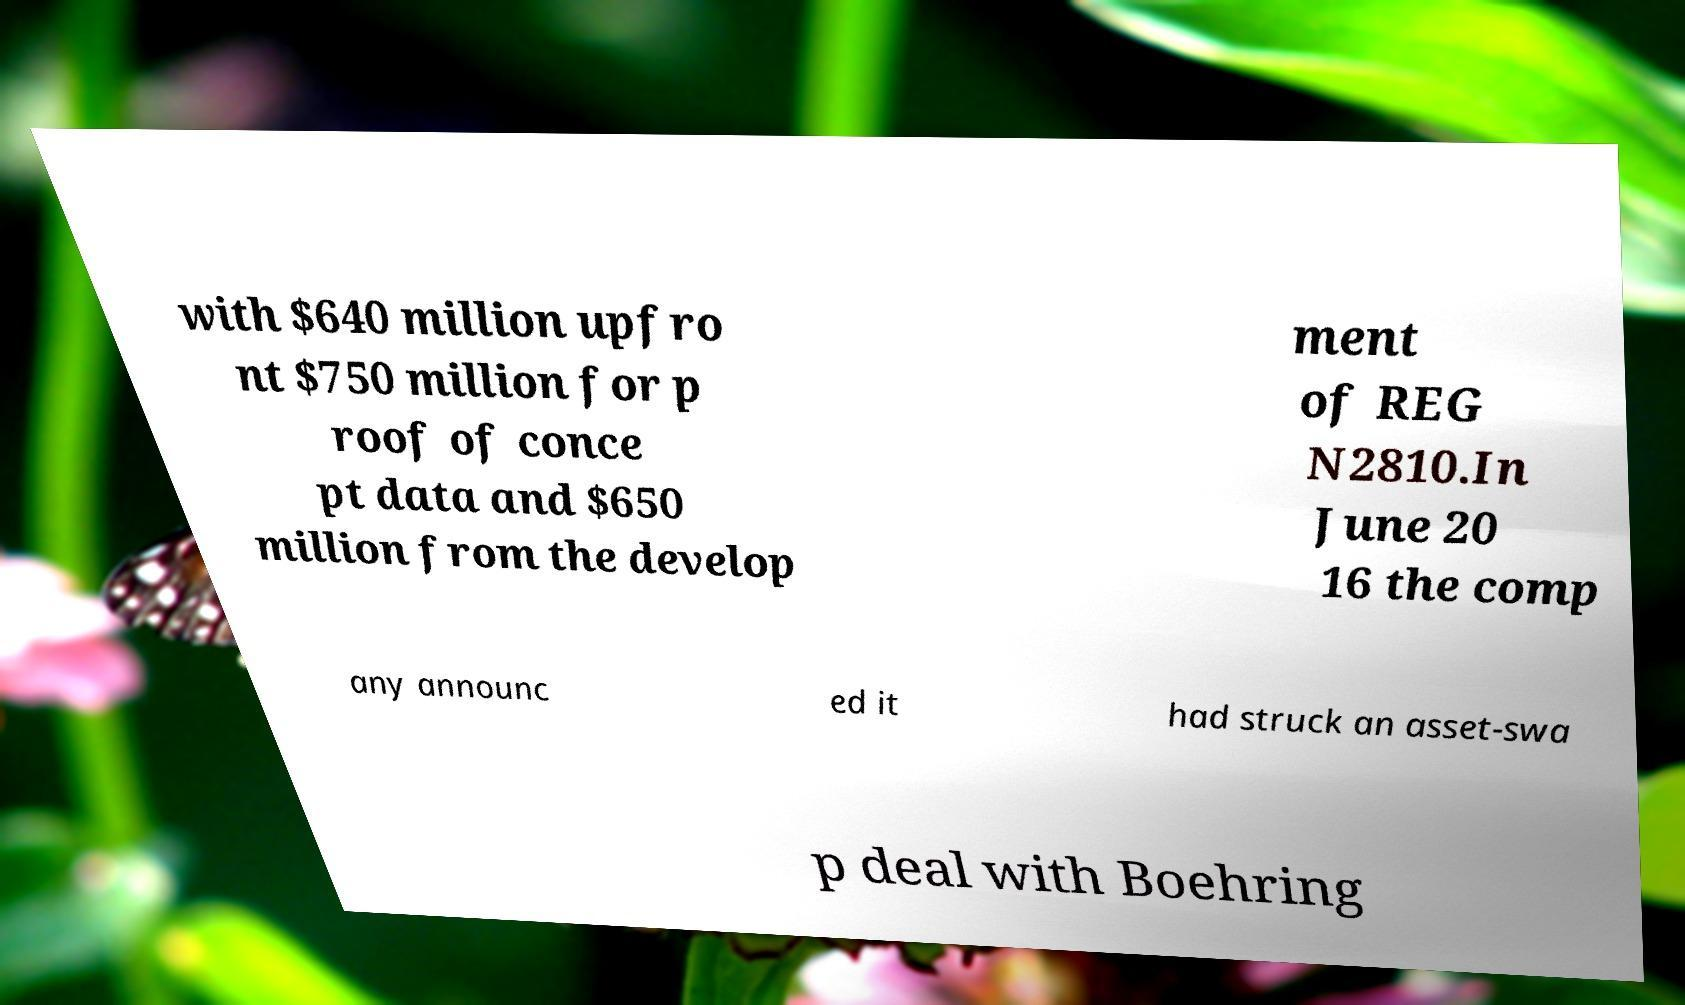Can you accurately transcribe the text from the provided image for me? with $640 million upfro nt $750 million for p roof of conce pt data and $650 million from the develop ment of REG N2810.In June 20 16 the comp any announc ed it had struck an asset-swa p deal with Boehring 